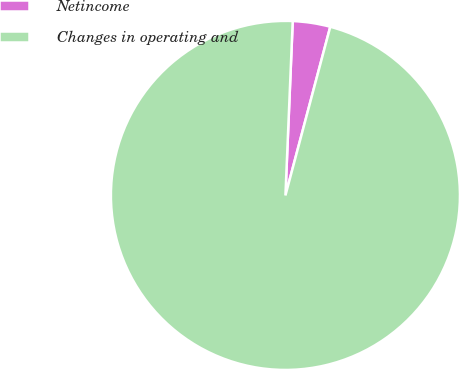<chart> <loc_0><loc_0><loc_500><loc_500><pie_chart><fcel>Netincome<fcel>Changes in operating and<nl><fcel>3.47%<fcel>96.53%<nl></chart> 